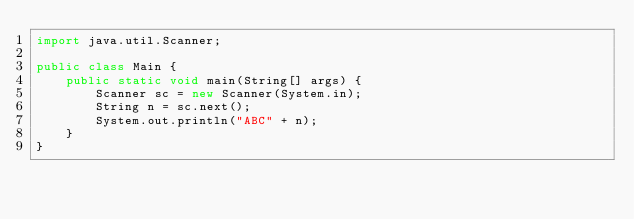<code> <loc_0><loc_0><loc_500><loc_500><_Java_>import java.util.Scanner;

public class Main {
    public static void main(String[] args) {
        Scanner sc = new Scanner(System.in);
        String n = sc.next();
        System.out.println("ABC" + n);
    }
}
</code> 